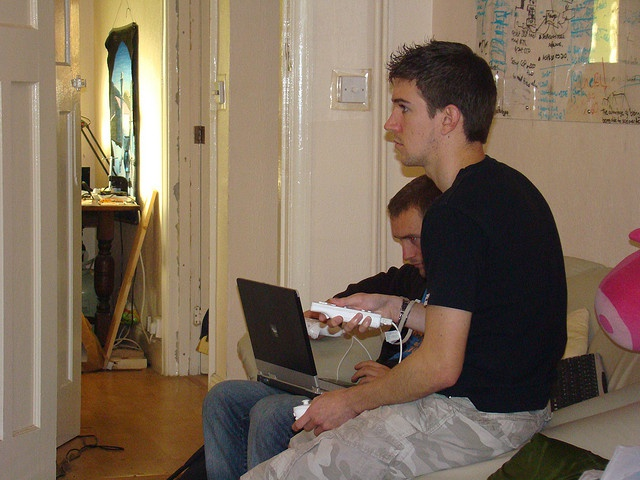Describe the objects in this image and their specific colors. I can see people in gray and black tones, couch in gray and black tones, laptop in gray and black tones, people in gray, black, maroon, and brown tones, and keyboard in black and gray tones in this image. 